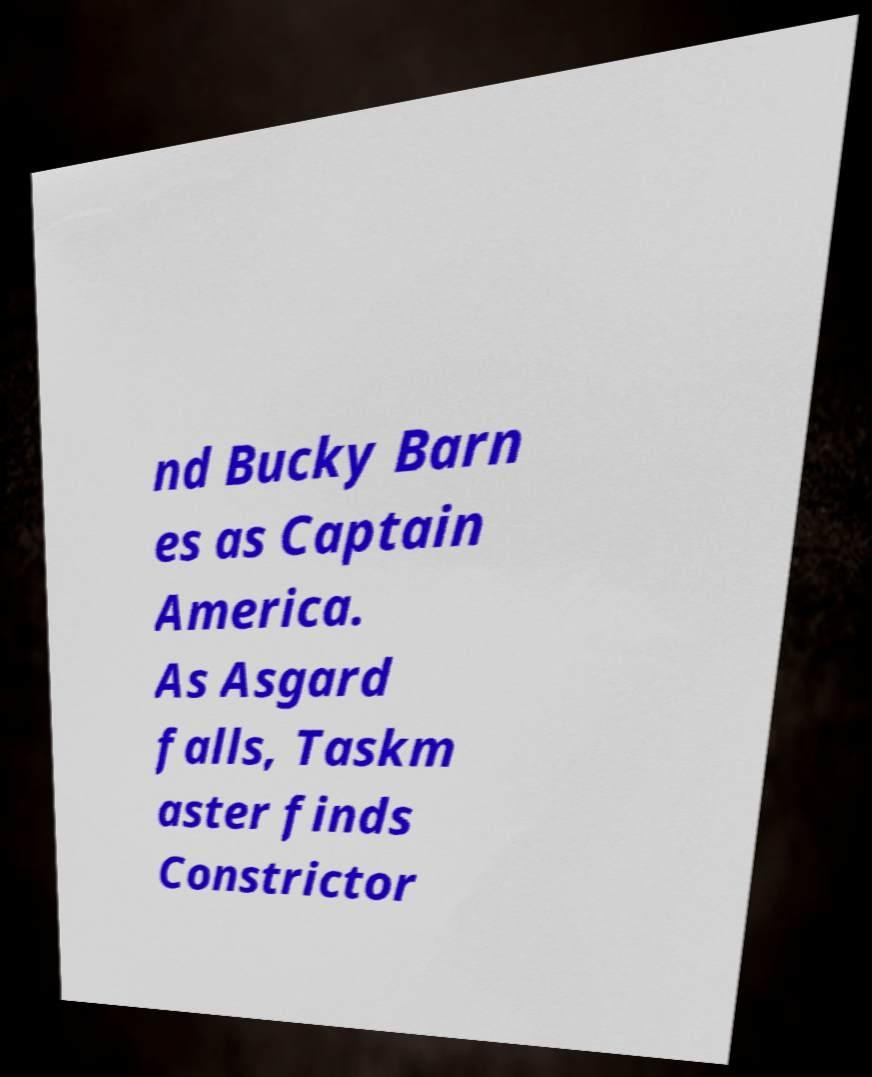Could you assist in decoding the text presented in this image and type it out clearly? nd Bucky Barn es as Captain America. As Asgard falls, Taskm aster finds Constrictor 